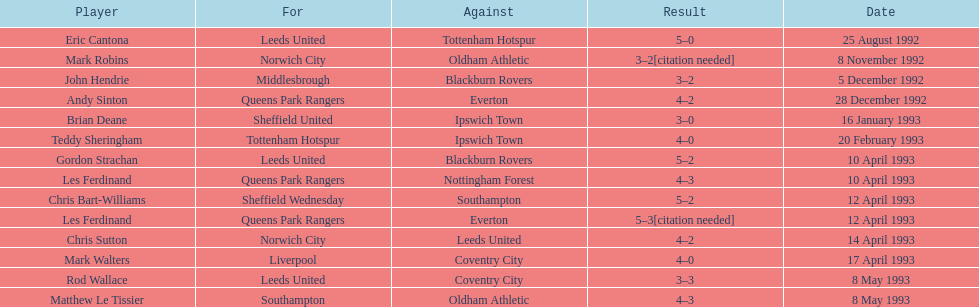Could you parse the entire table? {'header': ['Player', 'For', 'Against', 'Result', 'Date'], 'rows': [['Eric Cantona', 'Leeds United', 'Tottenham Hotspur', '5–0', '25 August 1992'], ['Mark Robins', 'Norwich City', 'Oldham Athletic', '3–2[citation needed]', '8 November 1992'], ['John Hendrie', 'Middlesbrough', 'Blackburn Rovers', '3–2', '5 December 1992'], ['Andy Sinton', 'Queens Park Rangers', 'Everton', '4–2', '28 December 1992'], ['Brian Deane', 'Sheffield United', 'Ipswich Town', '3–0', '16 January 1993'], ['Teddy Sheringham', 'Tottenham Hotspur', 'Ipswich Town', '4–0', '20 February 1993'], ['Gordon Strachan', 'Leeds United', 'Blackburn Rovers', '5–2', '10 April 1993'], ['Les Ferdinand', 'Queens Park Rangers', 'Nottingham Forest', '4–3', '10 April 1993'], ['Chris Bart-Williams', 'Sheffield Wednesday', 'Southampton', '5–2', '12 April 1993'], ['Les Ferdinand', 'Queens Park Rangers', 'Everton', '5–3[citation needed]', '12 April 1993'], ['Chris Sutton', 'Norwich City', 'Leeds United', '4–2', '14 April 1993'], ['Mark Walters', 'Liverpool', 'Coventry City', '4–0', '17 April 1993'], ['Rod Wallace', 'Leeds United', 'Coventry City', '3–3', '8 May 1993'], ['Matthew Le Tissier', 'Southampton', 'Oldham Athletic', '4–3', '8 May 1993']]} Which athlete had the identical outcome as mark robins? John Hendrie. 